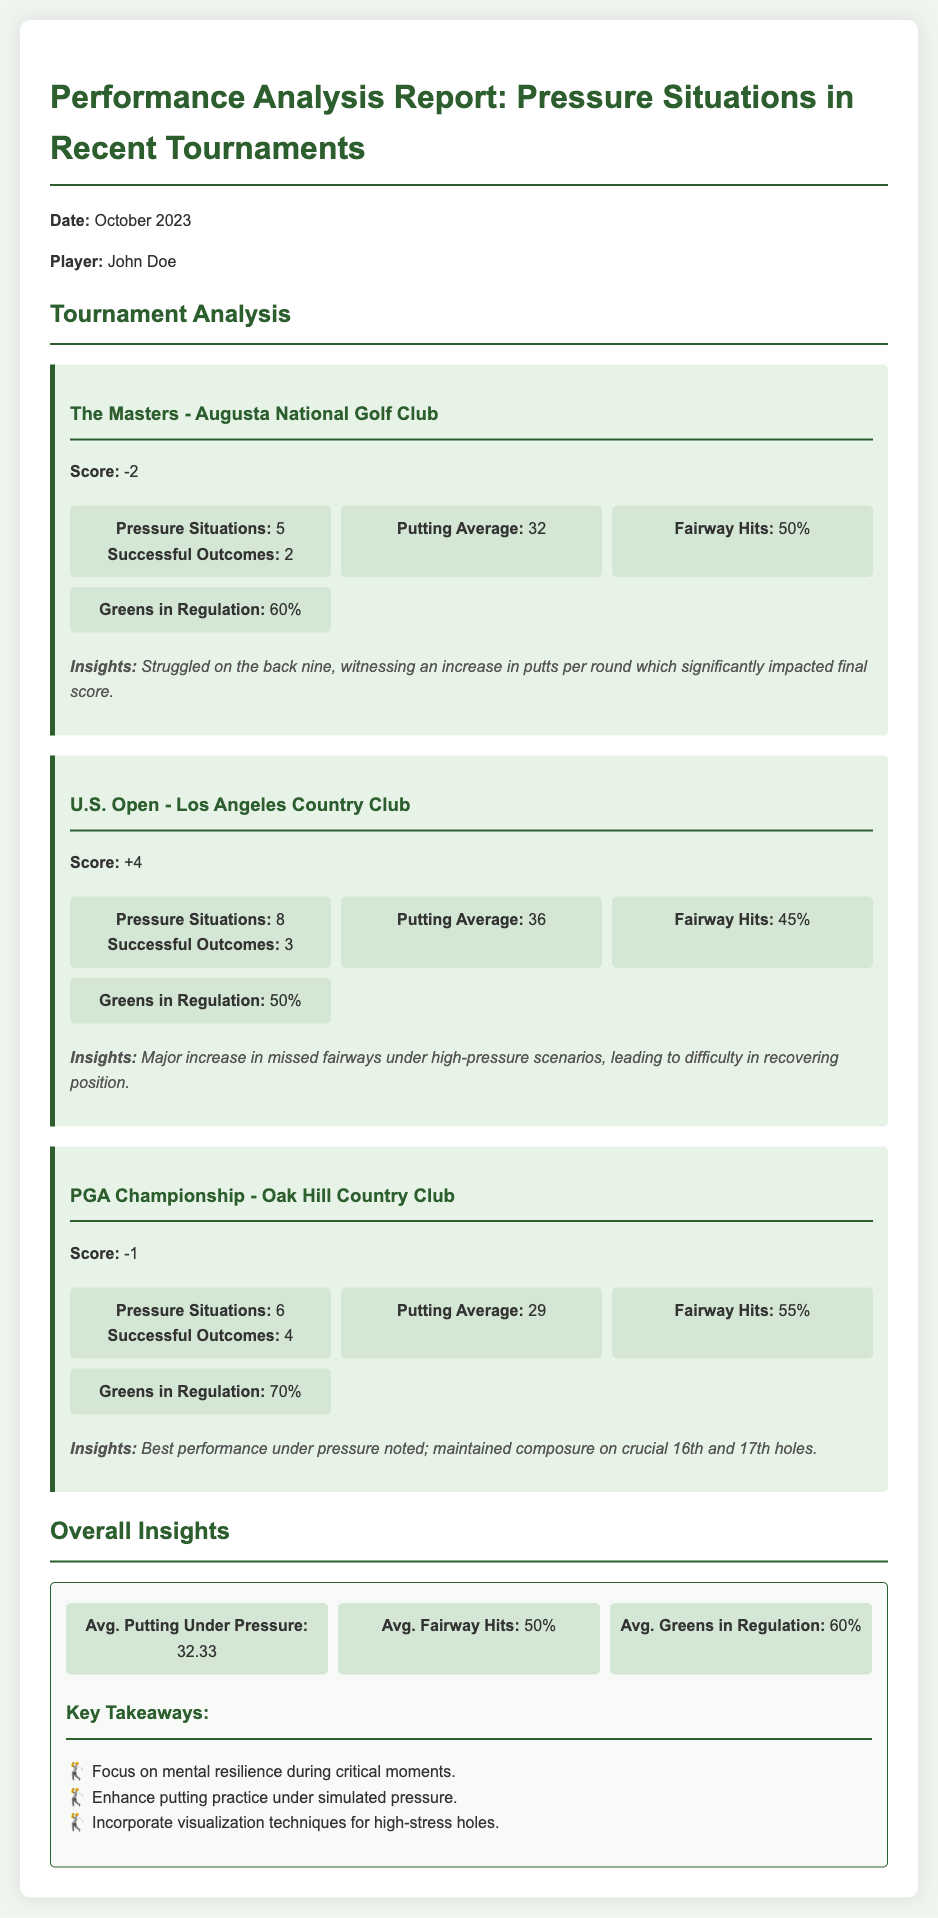What was the player's score in The Masters? The score for The Masters tournament is specifically mentioned in the report.
Answer: -2 How many pressure situations were encountered in the U.S. Open? The U.S. Open section of the report lists the number of pressure situations faced.
Answer: 8 What was the putting average in the PGA Championship? The putting average for the PGA Championship is stated directly in the tournament analysis.
Answer: 29 How many successful outcomes were recorded in pressure situations at The Masters? This information is included in the statistics for The Masters section of the report.
Answer: 2 Which tournament had the highest percentage of Greens in Regulation? The Greens in Regulation statistics are listed for each tournament, allowing comparison.
Answer: PGA Championship What are the average fairway hits across all tournaments mentioned? The average is noted in the overall insights section and combines data from all tournaments.
Answer: 50% What insights were drawn from performance under pressure in the PGA Championship? The insights section of the PGA Championship provides valuable notes on performance during pressure moments.
Answer: Best performance under pressure noted What should be improved according to key takeaways in the overall insights? The overall insights section lists suggestions for improvements needed based on performance analytics.
Answer: Enhance putting practice under simulated pressure How many tournaments are analyzed in this report? The report explicitly describes the number of tournaments analyzed within the performance analysis.
Answer: 3 